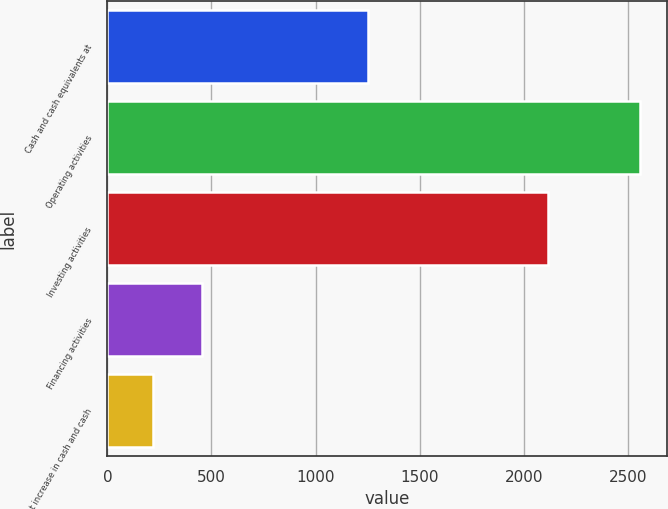Convert chart to OTSL. <chart><loc_0><loc_0><loc_500><loc_500><bar_chart><fcel>Cash and cash equivalents at<fcel>Operating activities<fcel>Investing activities<fcel>Financing activities<fcel>Net increase in cash and cash<nl><fcel>1253<fcel>2560<fcel>2118<fcel>454<fcel>220<nl></chart> 